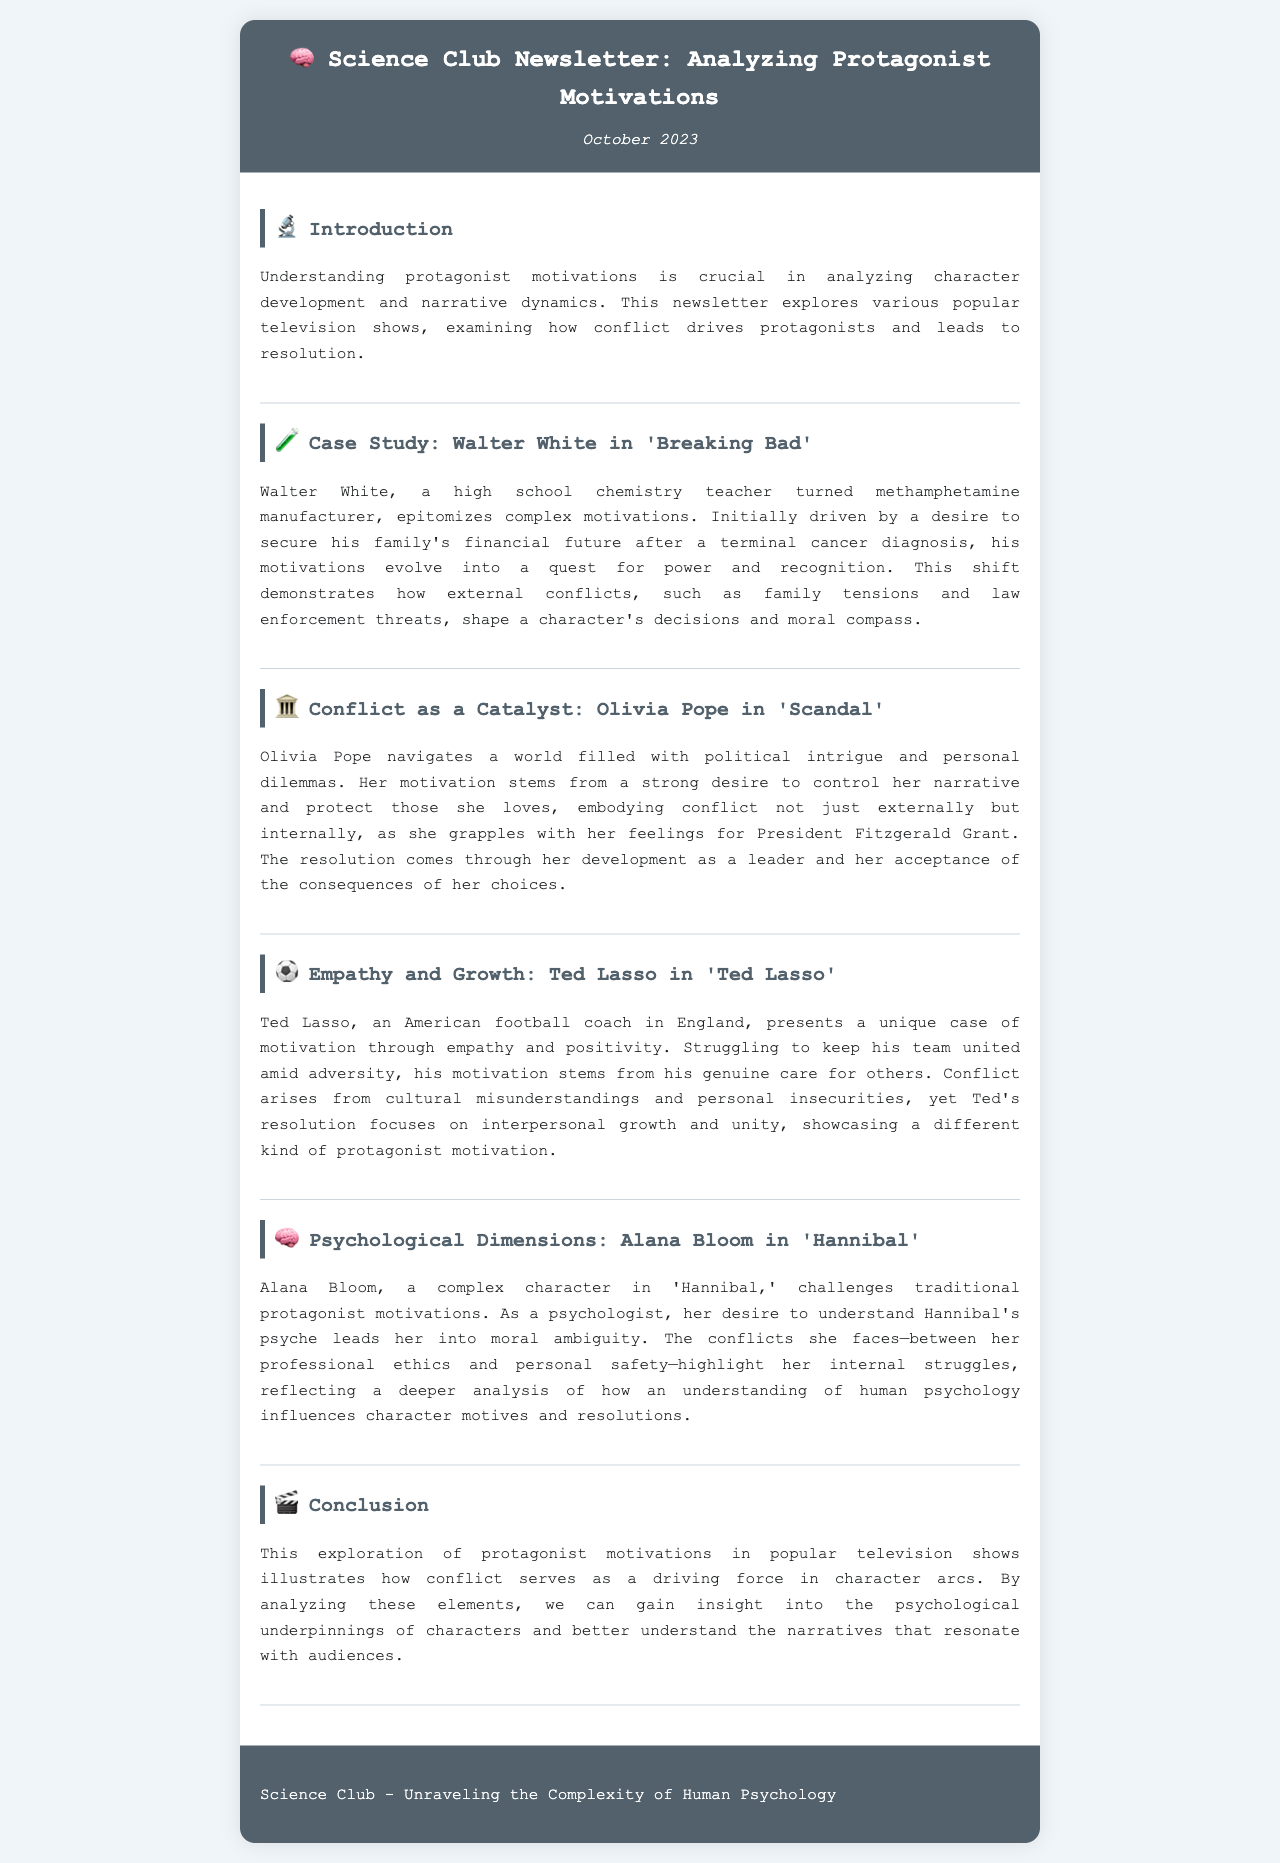What is the title of the newsletter? The title of the newsletter is stated prominently at the top of the document.
Answer: Analyzing Protagonist Motivations Who is the protagonist analyzed in 'Breaking Bad'? The newsletter mentions Walter White as the protagonist of 'Breaking Bad'.
Answer: Walter White What psychological theme is explored through Alana Bloom? The newsletter discusses Alana Bloom's character in relation to understanding human psychology.
Answer: Human psychology In which television show does Olivia Pope appear? The document specifies that Olivia Pope is a character in 'Scandal'.
Answer: Scandal How does Ted Lasso’s motivation primarily manifest? Ted Lasso's motivation is described as stemming from his genuine care for others.
Answer: Genuine care What serves as a driving force in character arcs, according to the document? The newsletter explains that conflict serves as the driving force in character arcs.
Answer: Conflict What is the date of the newsletter publication? The newsletter includes the publication date at the top of the document.
Answer: October 2023 Which character's motivations evolve from wanting financial security to a quest for power? The document details Walter White's evolving motivations throughout his story.
Answer: Walter White 